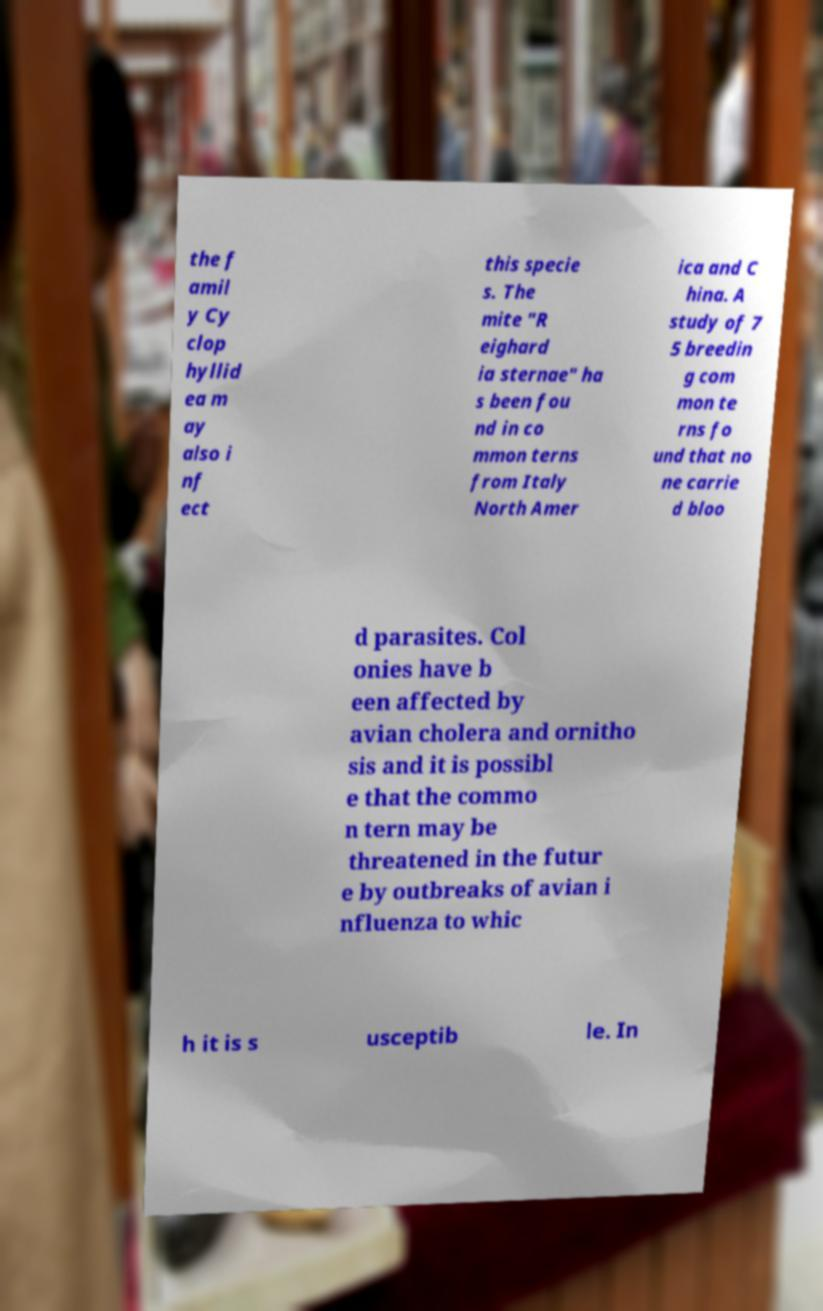There's text embedded in this image that I need extracted. Can you transcribe it verbatim? the f amil y Cy clop hyllid ea m ay also i nf ect this specie s. The mite "R eighard ia sternae" ha s been fou nd in co mmon terns from Italy North Amer ica and C hina. A study of 7 5 breedin g com mon te rns fo und that no ne carrie d bloo d parasites. Col onies have b een affected by avian cholera and ornitho sis and it is possibl e that the commo n tern may be threatened in the futur e by outbreaks of avian i nfluenza to whic h it is s usceptib le. In 